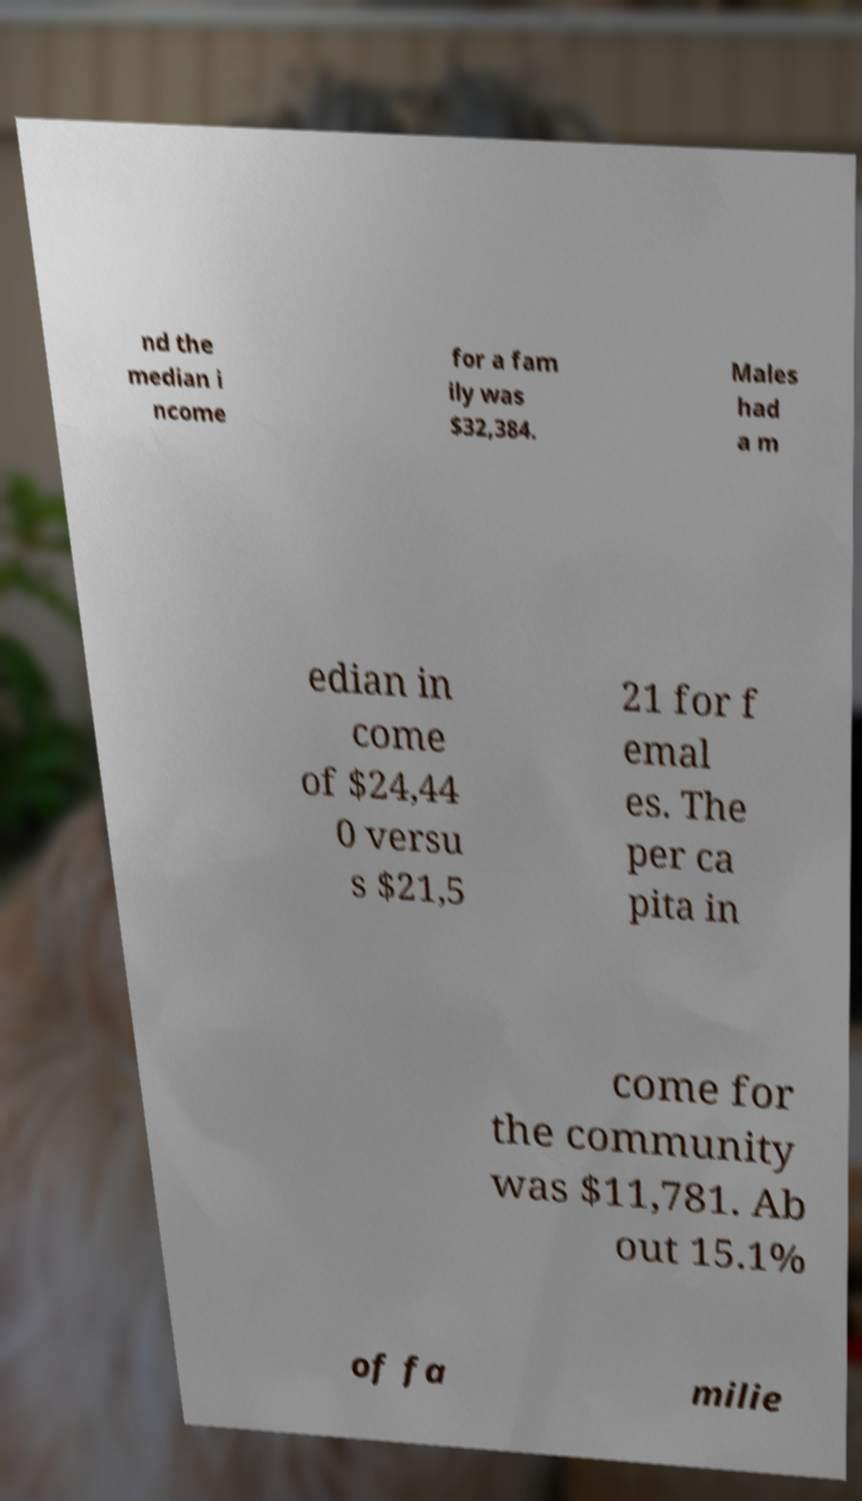Can you read and provide the text displayed in the image?This photo seems to have some interesting text. Can you extract and type it out for me? nd the median i ncome for a fam ily was $32,384. Males had a m edian in come of $24,44 0 versu s $21,5 21 for f emal es. The per ca pita in come for the community was $11,781. Ab out 15.1% of fa milie 